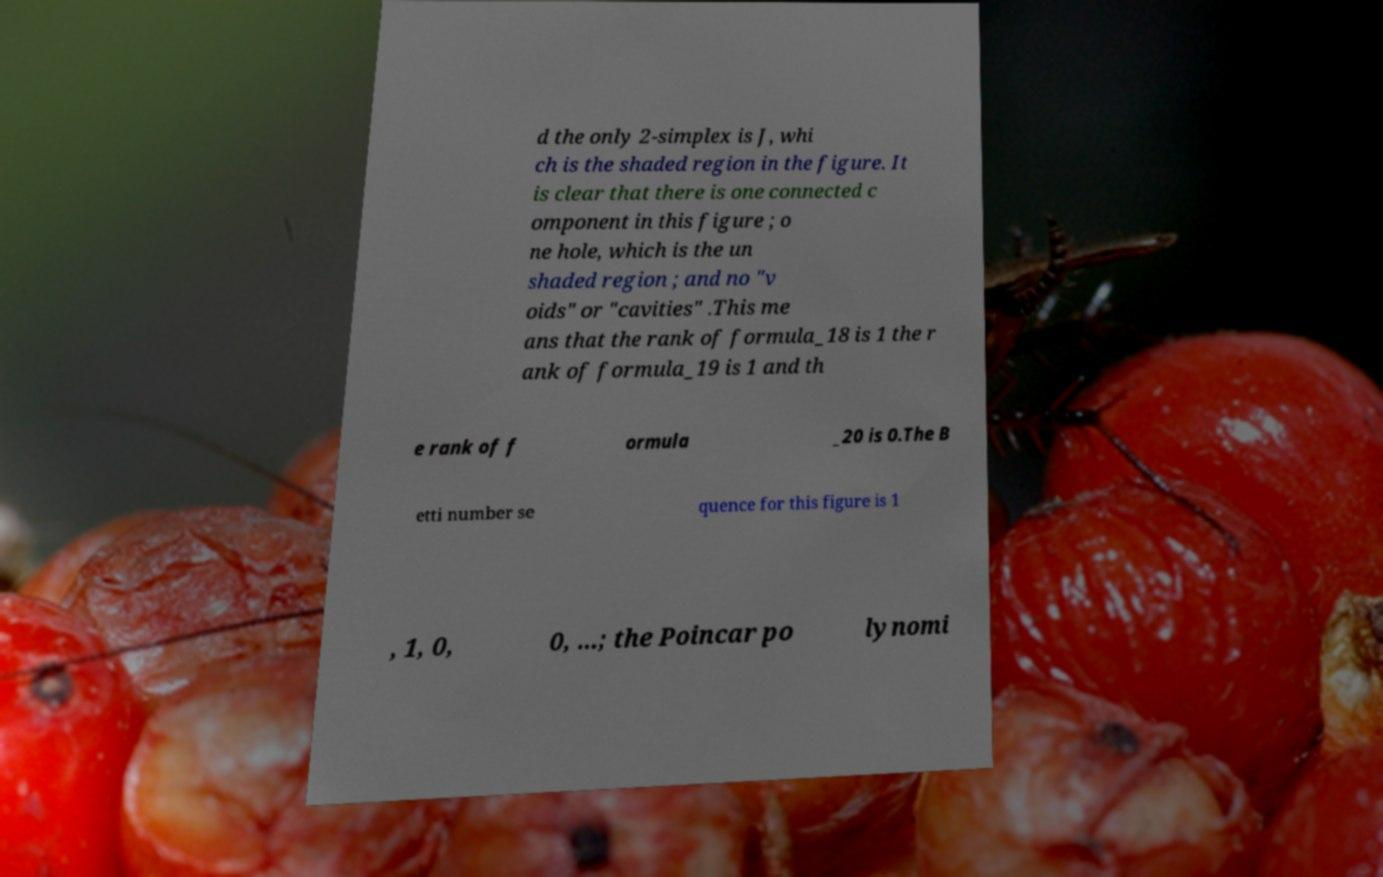What messages or text are displayed in this image? I need them in a readable, typed format. d the only 2-simplex is J, whi ch is the shaded region in the figure. It is clear that there is one connected c omponent in this figure ; o ne hole, which is the un shaded region ; and no "v oids" or "cavities" .This me ans that the rank of formula_18 is 1 the r ank of formula_19 is 1 and th e rank of f ormula _20 is 0.The B etti number se quence for this figure is 1 , 1, 0, 0, ...; the Poincar po lynomi 